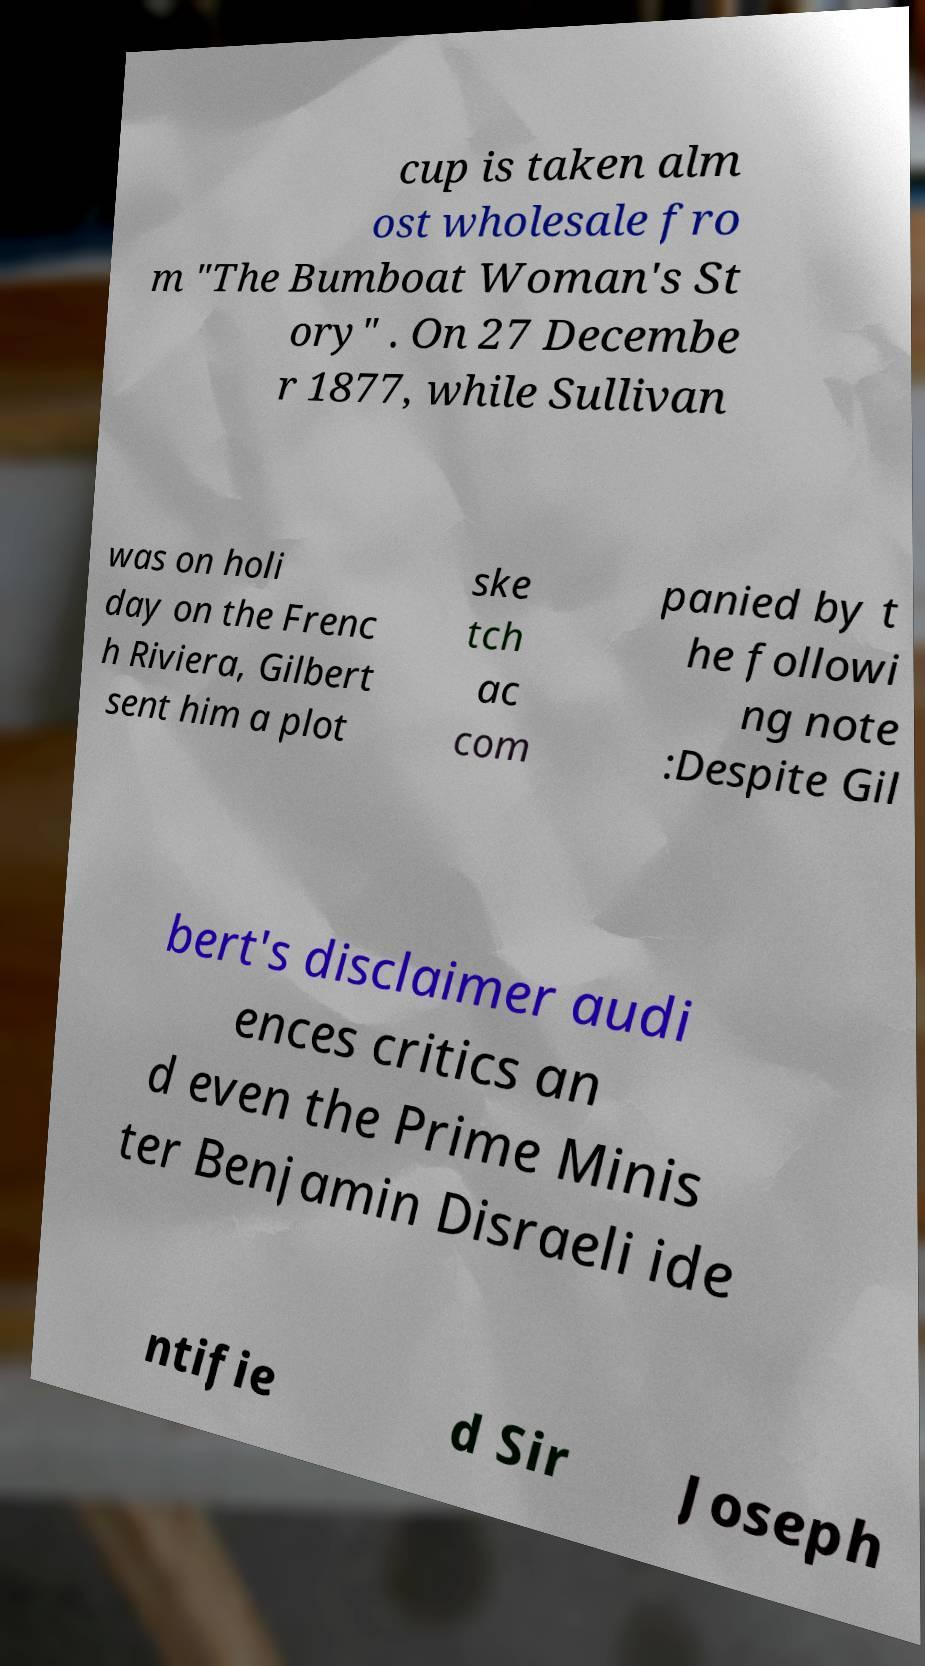Can you accurately transcribe the text from the provided image for me? cup is taken alm ost wholesale fro m "The Bumboat Woman's St ory" . On 27 Decembe r 1877, while Sullivan was on holi day on the Frenc h Riviera, Gilbert sent him a plot ske tch ac com panied by t he followi ng note :Despite Gil bert's disclaimer audi ences critics an d even the Prime Minis ter Benjamin Disraeli ide ntifie d Sir Joseph 